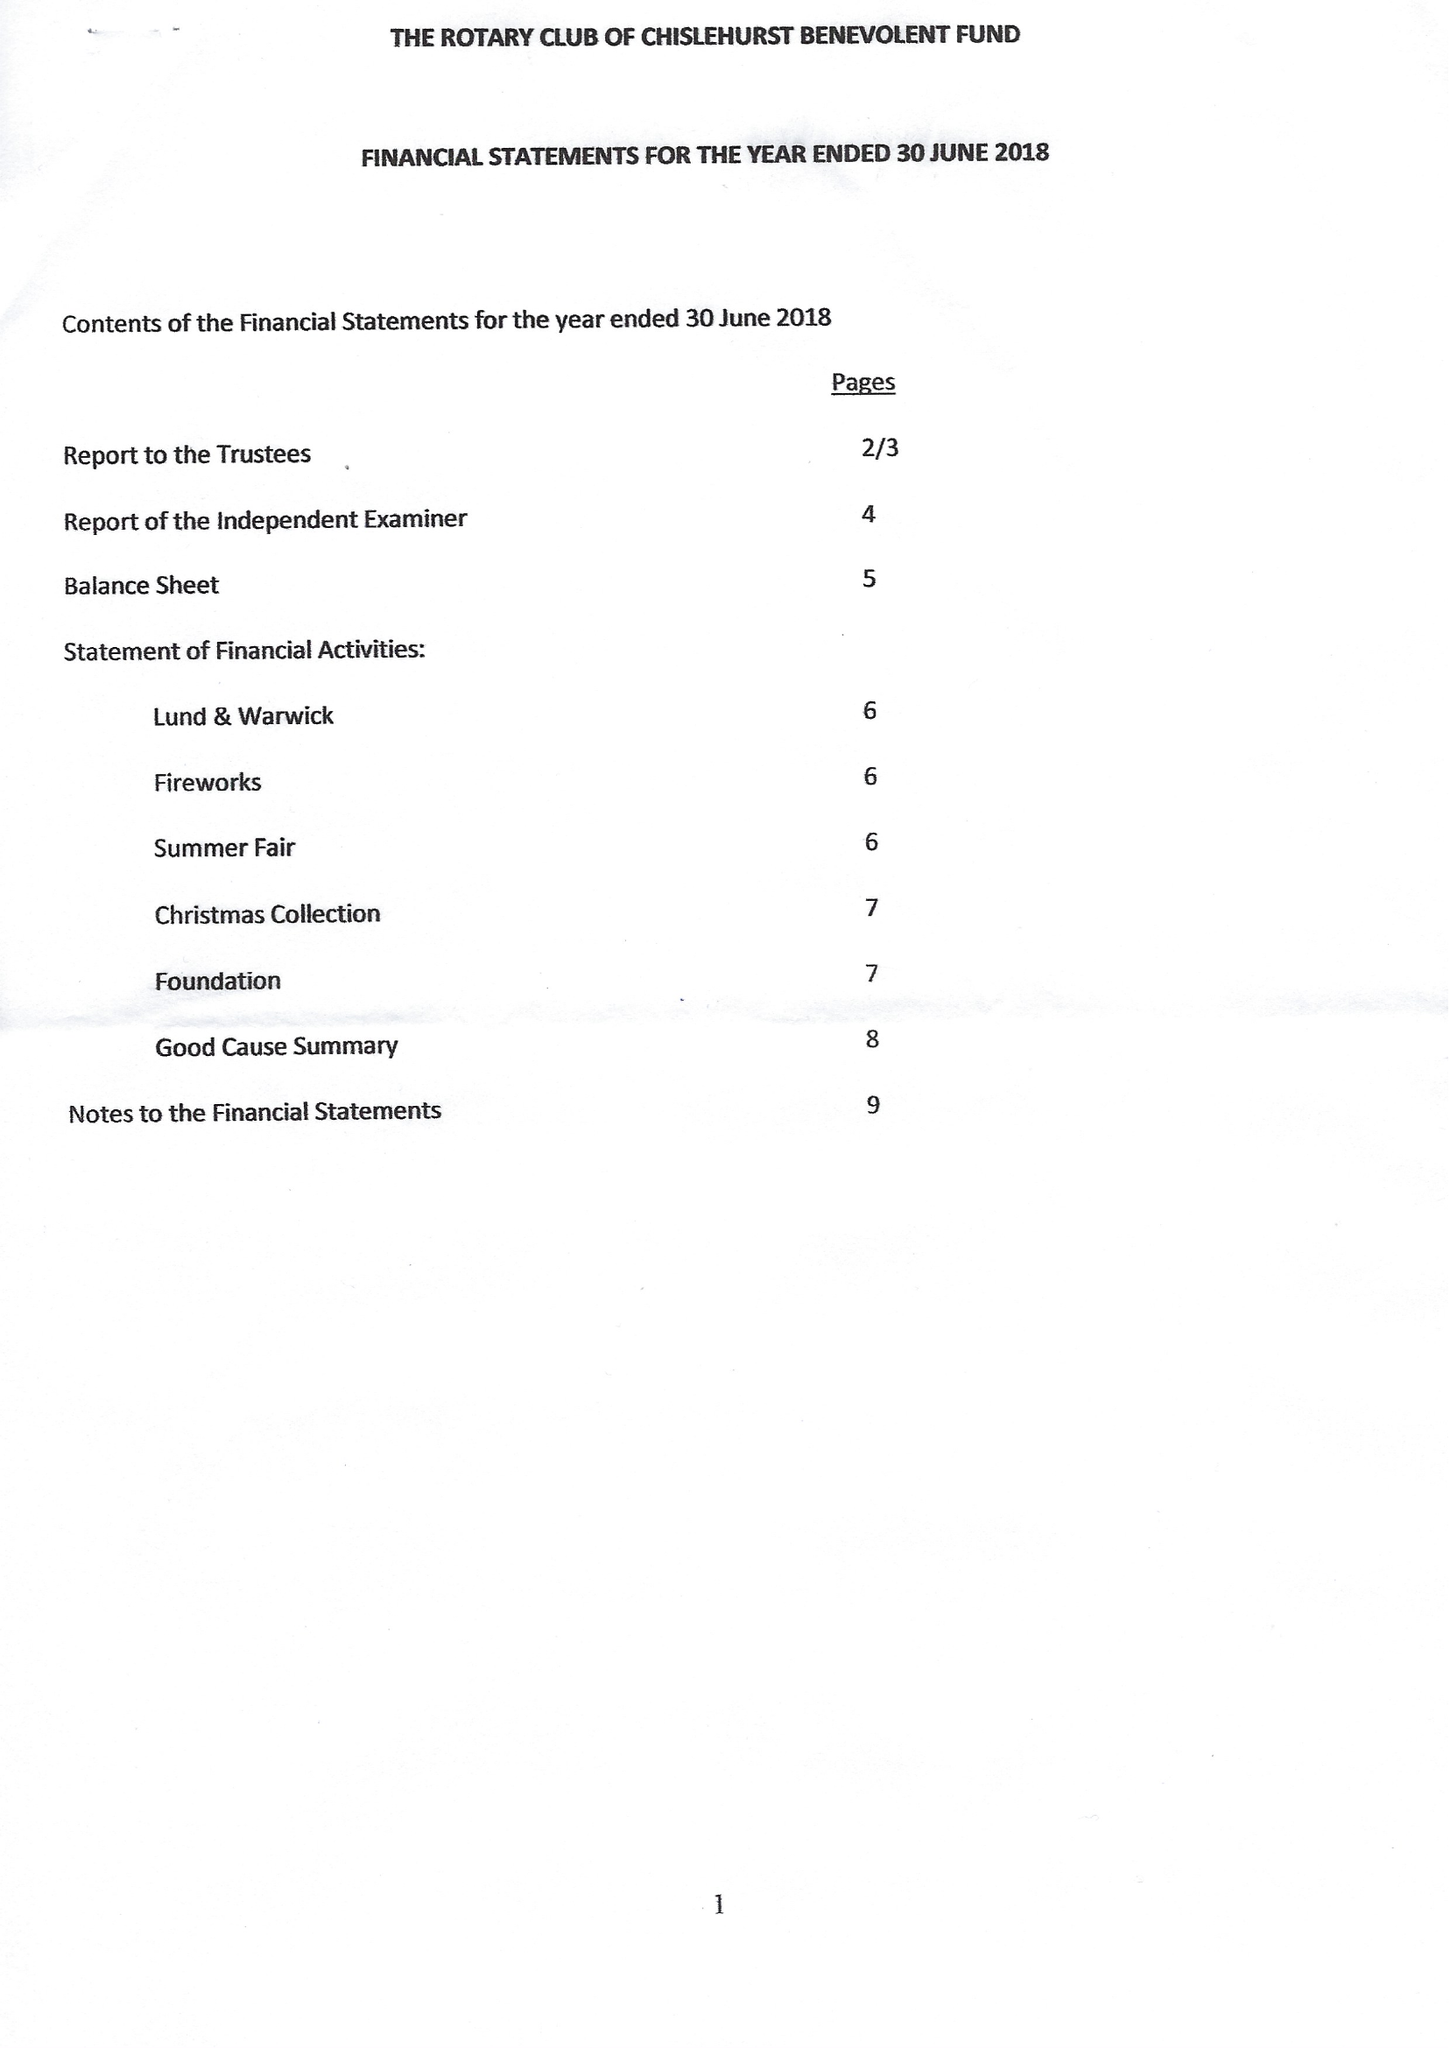What is the value for the address__street_line?
Answer the question using a single word or phrase. CHELSFIELD LANE 